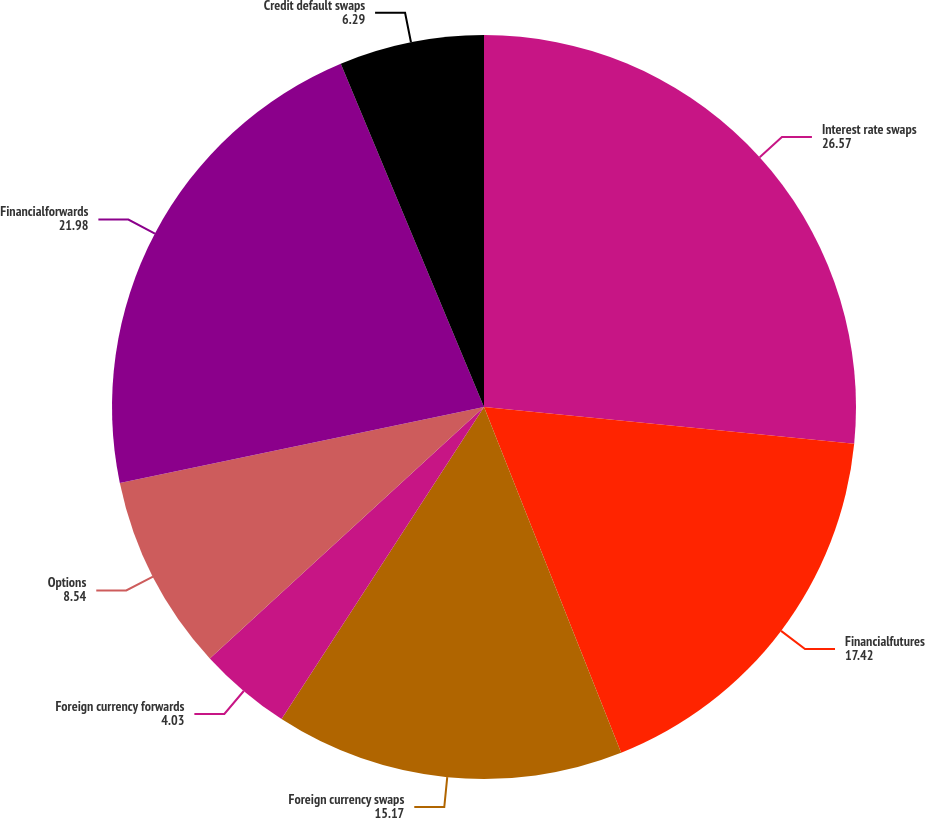Convert chart. <chart><loc_0><loc_0><loc_500><loc_500><pie_chart><fcel>Interest rate swaps<fcel>Financialfutures<fcel>Foreign currency swaps<fcel>Foreign currency forwards<fcel>Options<fcel>Financialforwards<fcel>Credit default swaps<nl><fcel>26.57%<fcel>17.42%<fcel>15.17%<fcel>4.03%<fcel>8.54%<fcel>21.98%<fcel>6.29%<nl></chart> 